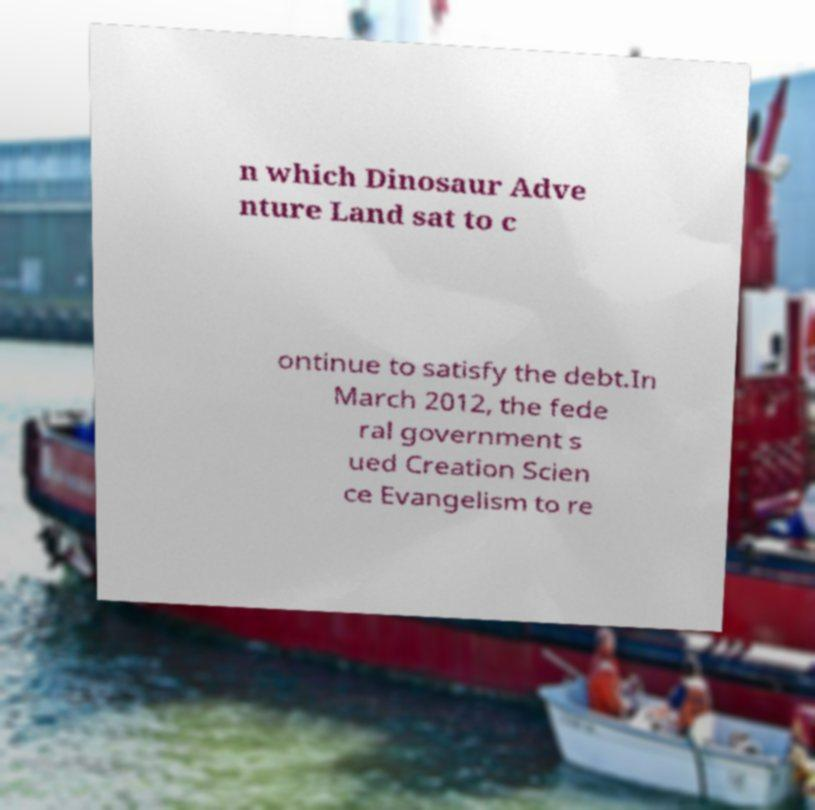Could you assist in decoding the text presented in this image and type it out clearly? n which Dinosaur Adve nture Land sat to c ontinue to satisfy the debt.In March 2012, the fede ral government s ued Creation Scien ce Evangelism to re 